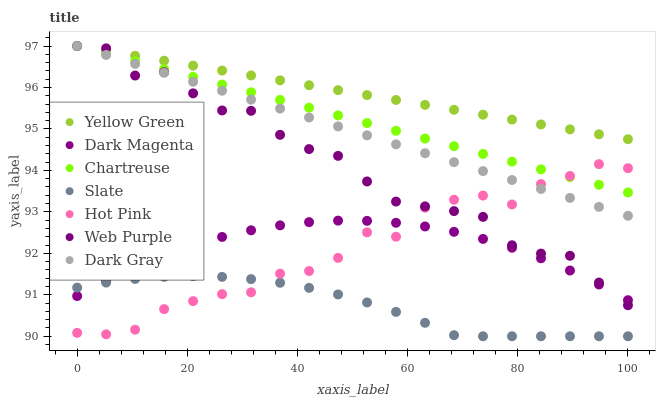Does Slate have the minimum area under the curve?
Answer yes or no. Yes. Does Yellow Green have the maximum area under the curve?
Answer yes or no. Yes. Does Hot Pink have the minimum area under the curve?
Answer yes or no. No. Does Hot Pink have the maximum area under the curve?
Answer yes or no. No. Is Yellow Green the smoothest?
Answer yes or no. Yes. Is Web Purple the roughest?
Answer yes or no. Yes. Is Slate the smoothest?
Answer yes or no. No. Is Slate the roughest?
Answer yes or no. No. Does Slate have the lowest value?
Answer yes or no. Yes. Does Hot Pink have the lowest value?
Answer yes or no. No. Does Web Purple have the highest value?
Answer yes or no. Yes. Does Hot Pink have the highest value?
Answer yes or no. No. Is Dark Magenta less than Chartreuse?
Answer yes or no. Yes. Is Chartreuse greater than Slate?
Answer yes or no. Yes. Does Dark Gray intersect Hot Pink?
Answer yes or no. Yes. Is Dark Gray less than Hot Pink?
Answer yes or no. No. Is Dark Gray greater than Hot Pink?
Answer yes or no. No. Does Dark Magenta intersect Chartreuse?
Answer yes or no. No. 